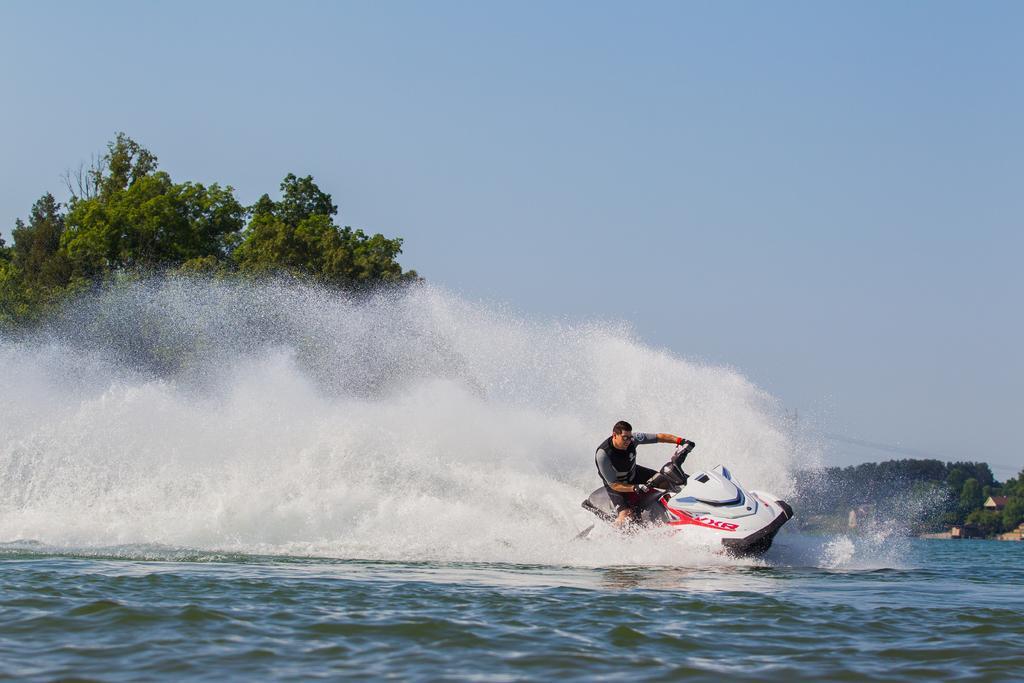Can you describe this image briefly? In this picture we can see a person riding a jet ski on the water and in the background we can see trees, sky and some objects. 